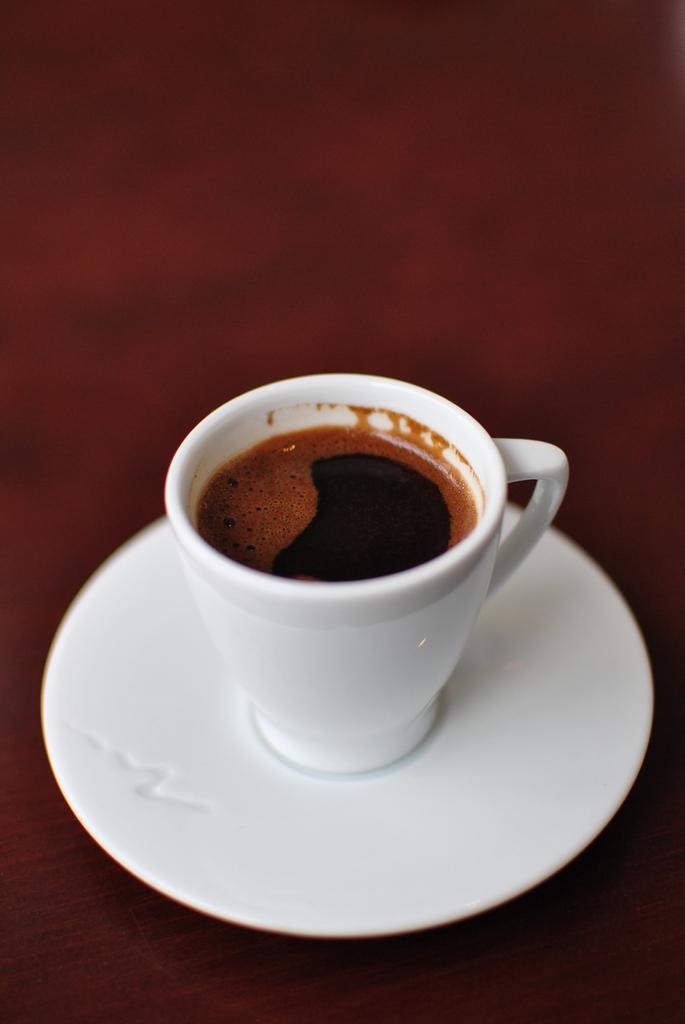Could you give a brief overview of what you see in this image? In this image we can see some liquid in the white cup on the white plate and there is a maroon color background. 